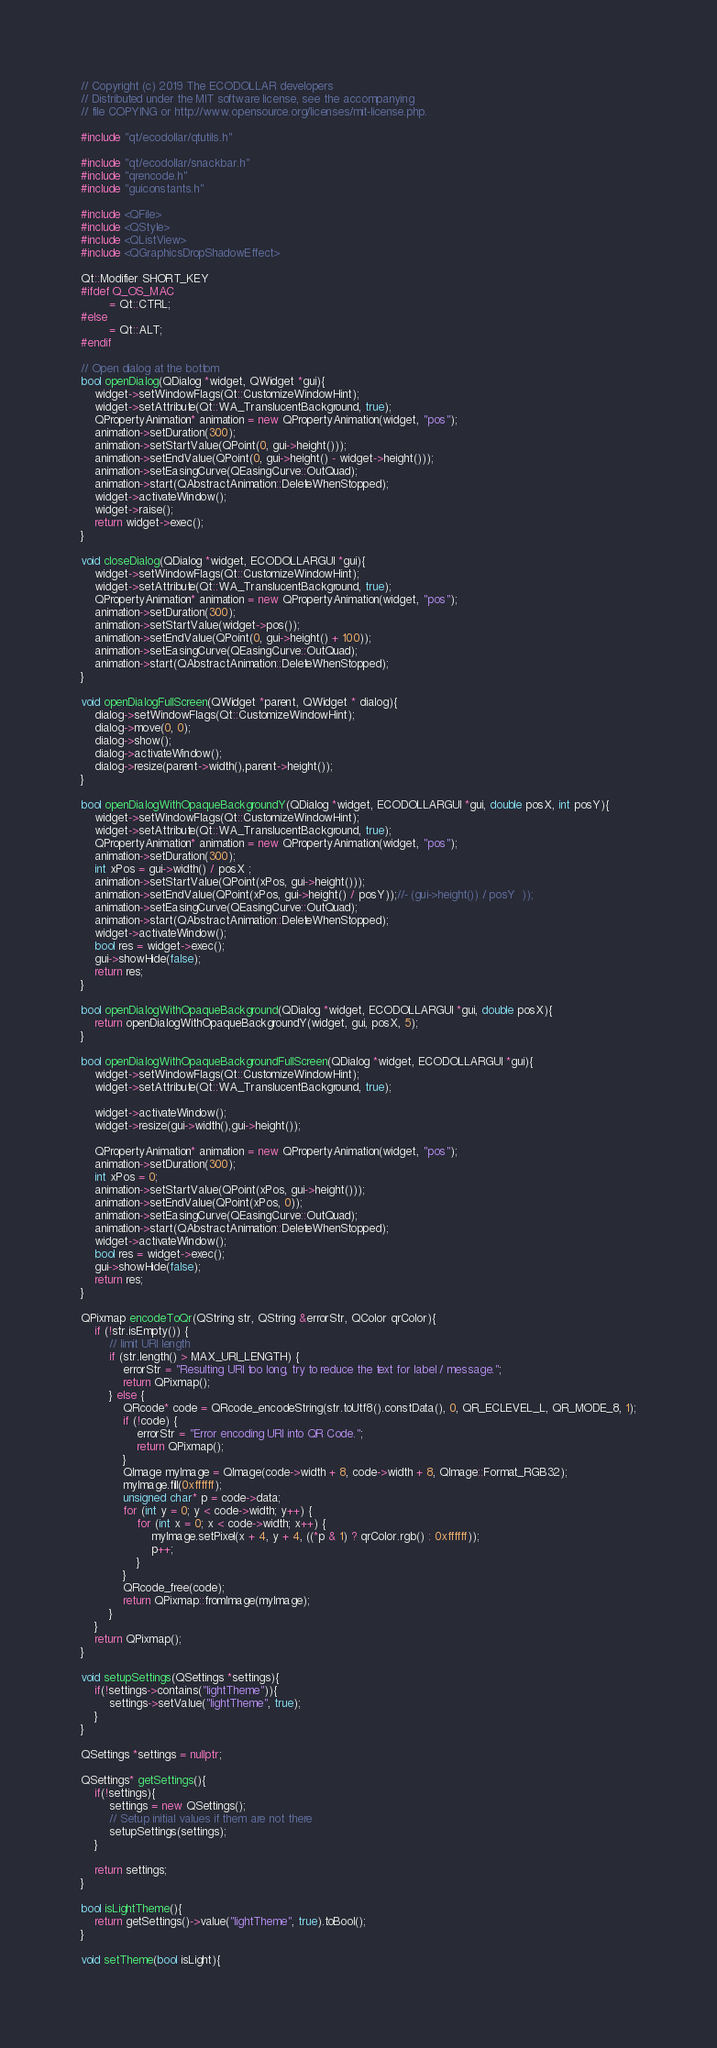<code> <loc_0><loc_0><loc_500><loc_500><_C++_>// Copyright (c) 2019 The ECODOLLAR developers
// Distributed under the MIT software license, see the accompanying
// file COPYING or http://www.opensource.org/licenses/mit-license.php.

#include "qt/ecodollar/qtutils.h"

#include "qt/ecodollar/snackbar.h"
#include "qrencode.h"
#include "guiconstants.h"

#include <QFile>
#include <QStyle>
#include <QListView>
#include <QGraphicsDropShadowEffect>

Qt::Modifier SHORT_KEY
#ifdef Q_OS_MAC
        = Qt::CTRL;
#else
        = Qt::ALT;
#endif

// Open dialog at the bottom
bool openDialog(QDialog *widget, QWidget *gui){
    widget->setWindowFlags(Qt::CustomizeWindowHint);
    widget->setAttribute(Qt::WA_TranslucentBackground, true);
    QPropertyAnimation* animation = new QPropertyAnimation(widget, "pos");
    animation->setDuration(300);
    animation->setStartValue(QPoint(0, gui->height()));
    animation->setEndValue(QPoint(0, gui->height() - widget->height()));
    animation->setEasingCurve(QEasingCurve::OutQuad);
    animation->start(QAbstractAnimation::DeleteWhenStopped);
    widget->activateWindow();
    widget->raise();
    return widget->exec();
}

void closeDialog(QDialog *widget, ECODOLLARGUI *gui){
    widget->setWindowFlags(Qt::CustomizeWindowHint);
    widget->setAttribute(Qt::WA_TranslucentBackground, true);
    QPropertyAnimation* animation = new QPropertyAnimation(widget, "pos");
    animation->setDuration(300);
    animation->setStartValue(widget->pos());
    animation->setEndValue(QPoint(0, gui->height() + 100));
    animation->setEasingCurve(QEasingCurve::OutQuad);
    animation->start(QAbstractAnimation::DeleteWhenStopped);
}

void openDialogFullScreen(QWidget *parent, QWidget * dialog){
    dialog->setWindowFlags(Qt::CustomizeWindowHint);
    dialog->move(0, 0);
    dialog->show();
    dialog->activateWindow();
    dialog->resize(parent->width(),parent->height());
}

bool openDialogWithOpaqueBackgroundY(QDialog *widget, ECODOLLARGUI *gui, double posX, int posY){
    widget->setWindowFlags(Qt::CustomizeWindowHint);
    widget->setAttribute(Qt::WA_TranslucentBackground, true);
    QPropertyAnimation* animation = new QPropertyAnimation(widget, "pos");
    animation->setDuration(300);
    int xPos = gui->width() / posX ;
    animation->setStartValue(QPoint(xPos, gui->height()));
    animation->setEndValue(QPoint(xPos, gui->height() / posY));//- (gui->height()) / posY  ));
    animation->setEasingCurve(QEasingCurve::OutQuad);
    animation->start(QAbstractAnimation::DeleteWhenStopped);
    widget->activateWindow();
    bool res = widget->exec();
    gui->showHide(false);
    return res;
}

bool openDialogWithOpaqueBackground(QDialog *widget, ECODOLLARGUI *gui, double posX){
    return openDialogWithOpaqueBackgroundY(widget, gui, posX, 5);
}

bool openDialogWithOpaqueBackgroundFullScreen(QDialog *widget, ECODOLLARGUI *gui){
    widget->setWindowFlags(Qt::CustomizeWindowHint);
    widget->setAttribute(Qt::WA_TranslucentBackground, true);

    widget->activateWindow();
    widget->resize(gui->width(),gui->height());

    QPropertyAnimation* animation = new QPropertyAnimation(widget, "pos");
    animation->setDuration(300);
    int xPos = 0;
    animation->setStartValue(QPoint(xPos, gui->height()));
    animation->setEndValue(QPoint(xPos, 0));
    animation->setEasingCurve(QEasingCurve::OutQuad);
    animation->start(QAbstractAnimation::DeleteWhenStopped);
    widget->activateWindow();
    bool res = widget->exec();
    gui->showHide(false);
    return res;
}

QPixmap encodeToQr(QString str, QString &errorStr, QColor qrColor){
    if (!str.isEmpty()) {
        // limit URI length
        if (str.length() > MAX_URI_LENGTH) {
            errorStr = "Resulting URI too long, try to reduce the text for label / message.";
            return QPixmap();
        } else {
            QRcode* code = QRcode_encodeString(str.toUtf8().constData(), 0, QR_ECLEVEL_L, QR_MODE_8, 1);
            if (!code) {
                errorStr = "Error encoding URI into QR Code.";
                return QPixmap();
            }
            QImage myImage = QImage(code->width + 8, code->width + 8, QImage::Format_RGB32);
            myImage.fill(0xffffff);
            unsigned char* p = code->data;
            for (int y = 0; y < code->width; y++) {
                for (int x = 0; x < code->width; x++) {
                    myImage.setPixel(x + 4, y + 4, ((*p & 1) ? qrColor.rgb() : 0xffffff));
                    p++;
                }
            }
            QRcode_free(code);
            return QPixmap::fromImage(myImage);
        }
    }
    return QPixmap();
}

void setupSettings(QSettings *settings){
    if(!settings->contains("lightTheme")){
        settings->setValue("lightTheme", true);
    }
}

QSettings *settings = nullptr;

QSettings* getSettings(){
    if(!settings){
        settings = new QSettings();
        // Setup initial values if them are not there
        setupSettings(settings);
    }

    return settings;
}

bool isLightTheme(){
    return getSettings()->value("lightTheme", true).toBool();
}

void setTheme(bool isLight){</code> 